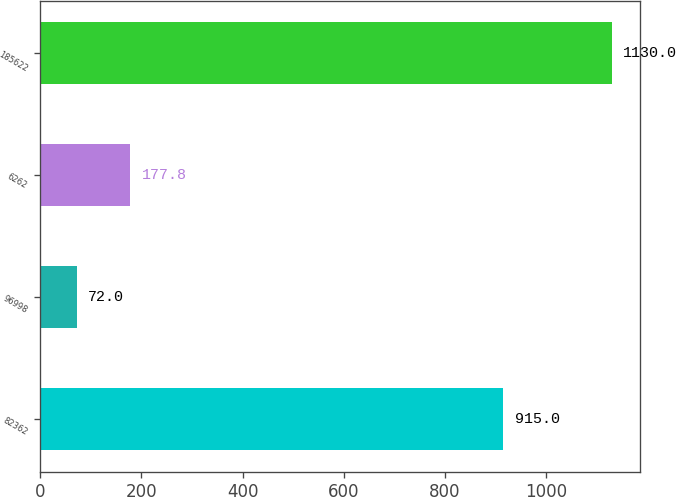<chart> <loc_0><loc_0><loc_500><loc_500><bar_chart><fcel>82362<fcel>96998<fcel>6262<fcel>185622<nl><fcel>915<fcel>72<fcel>177.8<fcel>1130<nl></chart> 